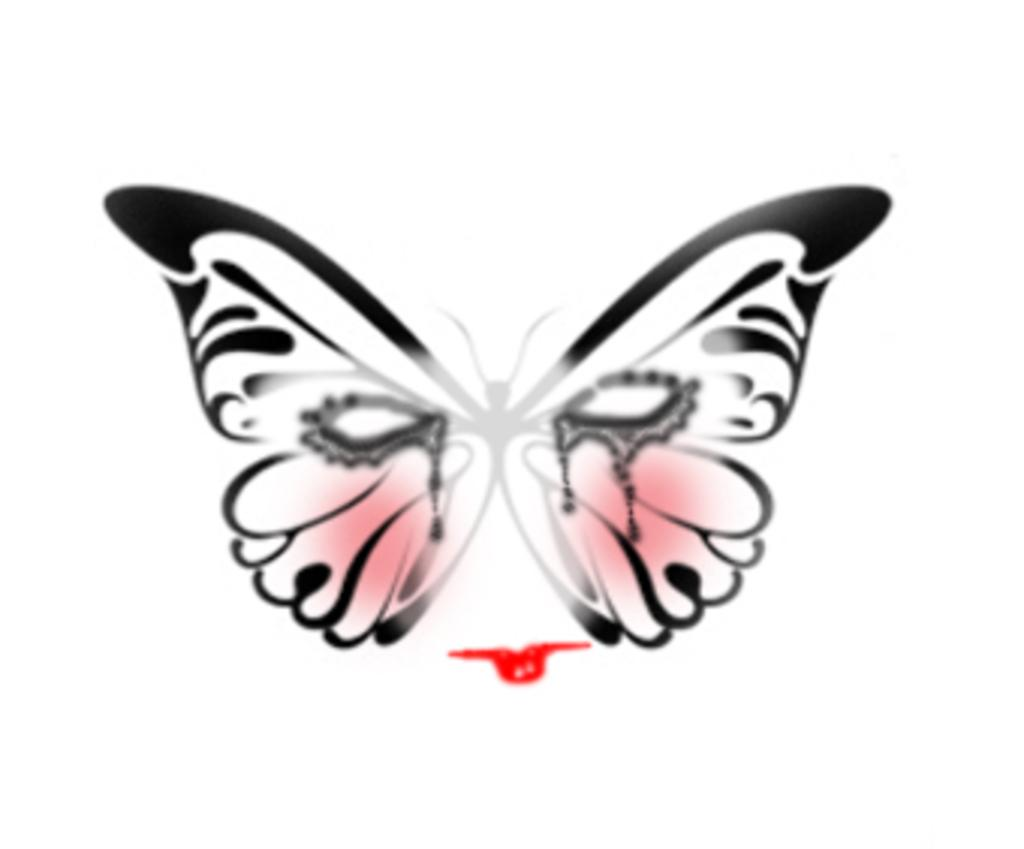What is depicted in the image? There is a drawing of a butterfly in the image. Can you describe the subject of the drawing? The drawing features a butterfly. What type of space exploration is depicted in the image? There is no space exploration depicted in the image; it features a drawing of a butterfly. What color is the shirt worn by the butterfly in the image? There is no shirt or butterfly wearing a shirt present in the image; it is a drawing of a butterfly. 